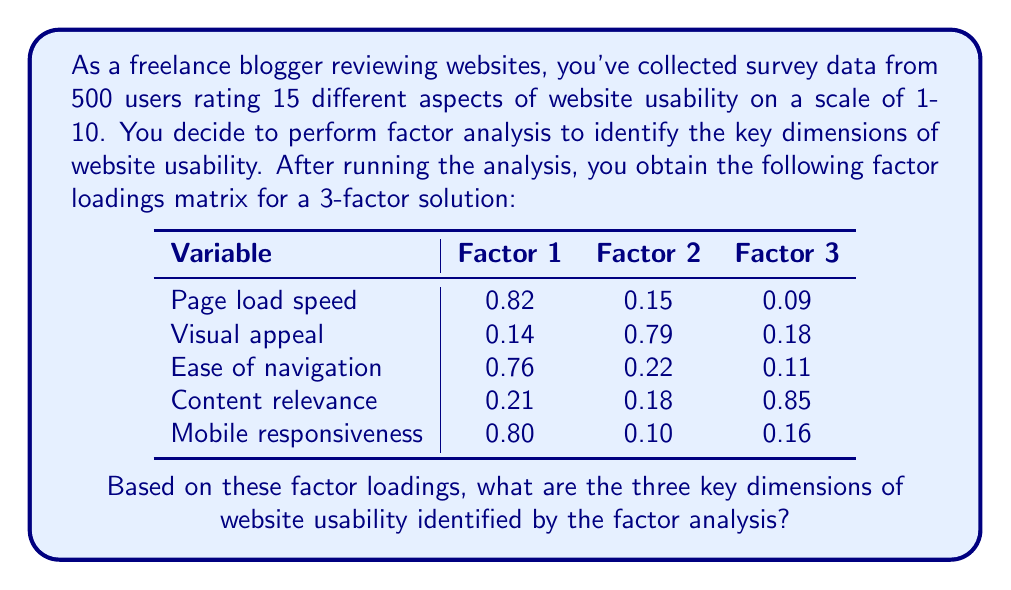Can you answer this question? To identify the key dimensions of website usability from the factor analysis results, we need to interpret the factor loadings matrix. Here's a step-by-step approach:

1. Examine the factor loadings for each variable across the three factors.
2. Identify which factor has the highest loading for each variable.
3. Group variables with high loadings on the same factor.
4. Interpret and name each factor based on the variables it represents.

Let's analyze each factor:

Factor 1:
- High loadings: Page load speed (0.82), Ease of navigation (0.76), Mobile responsiveness (0.80)
- These variables relate to the technical performance and functionality of the website.
- We can label this factor as "Technical Performance"

Factor 2:
- High loading: Visual appeal (0.79)
- This factor primarily represents the aesthetic aspect of the website.
- We can label this factor as "Visual Design"

Factor 3:
- High loading: Content relevance (0.85)
- This factor represents the quality and appropriateness of the website's content.
- We can label this factor as "Content Quality"

Therefore, the three key dimensions of website usability identified by the factor analysis are:
1. Technical Performance
2. Visual Design
3. Content Quality
Answer: Technical Performance, Visual Design, Content Quality 